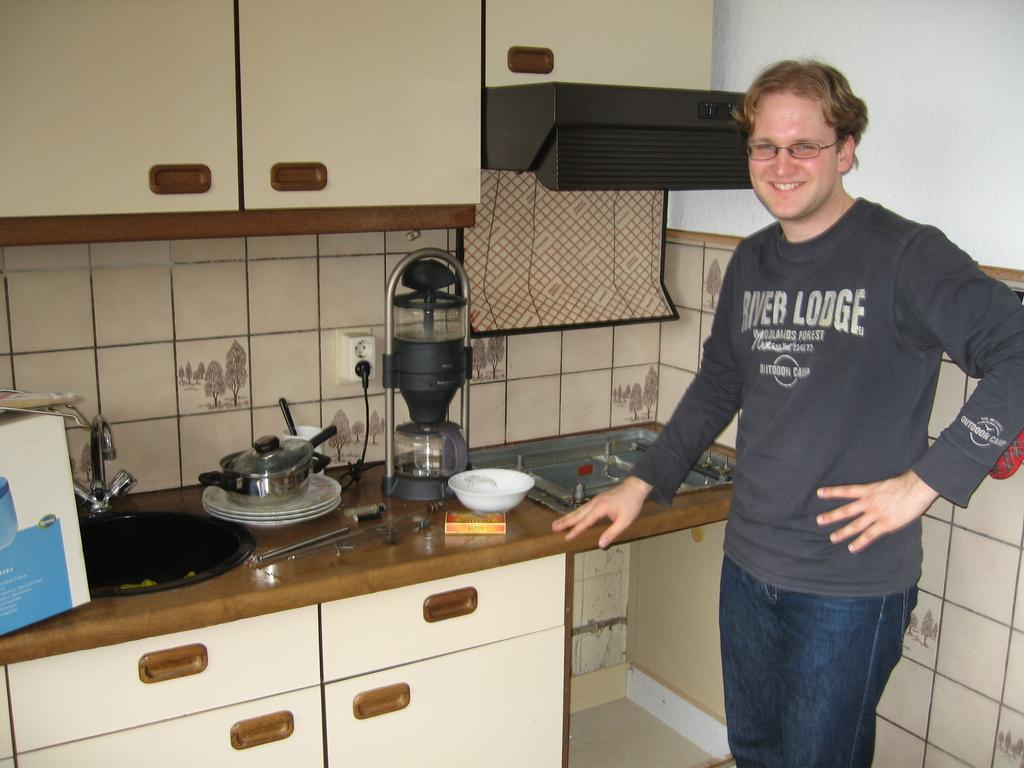<image>
Summarize the visual content of the image. A man standing in the kitchen wearing a long sleeved shirt with the words River Lodge on it. 